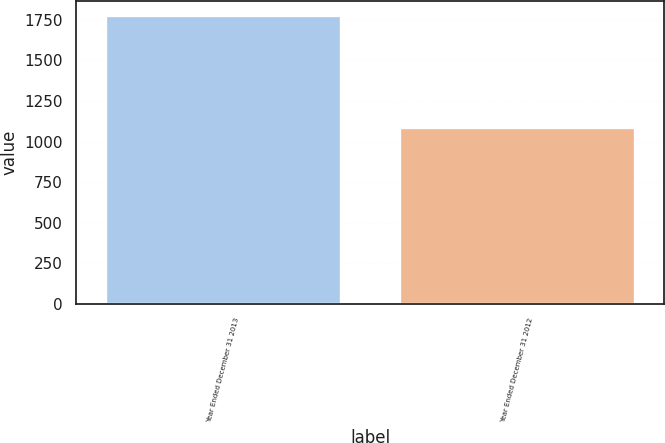Convert chart. <chart><loc_0><loc_0><loc_500><loc_500><bar_chart><fcel>Year Ended December 31 2013<fcel>Year Ended December 31 2012<nl><fcel>1778<fcel>1087<nl></chart> 